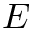<formula> <loc_0><loc_0><loc_500><loc_500>E</formula> 